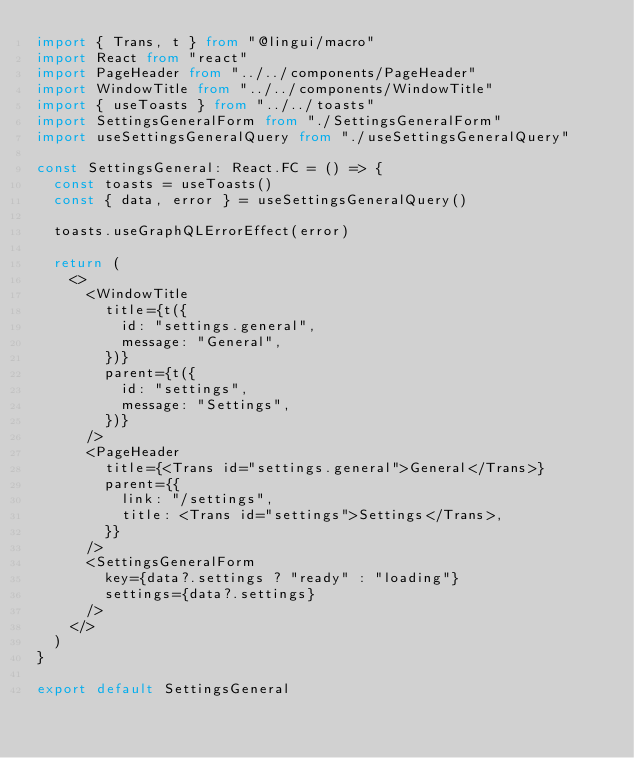<code> <loc_0><loc_0><loc_500><loc_500><_TypeScript_>import { Trans, t } from "@lingui/macro"
import React from "react"
import PageHeader from "../../components/PageHeader"
import WindowTitle from "../../components/WindowTitle"
import { useToasts } from "../../toasts"
import SettingsGeneralForm from "./SettingsGeneralForm"
import useSettingsGeneralQuery from "./useSettingsGeneralQuery"

const SettingsGeneral: React.FC = () => {
  const toasts = useToasts()
  const { data, error } = useSettingsGeneralQuery()

  toasts.useGraphQLErrorEffect(error)

  return (
    <>
      <WindowTitle
        title={t({
          id: "settings.general",
          message: "General",
        })}
        parent={t({
          id: "settings",
          message: "Settings",
        })}
      />
      <PageHeader
        title={<Trans id="settings.general">General</Trans>}
        parent={{
          link: "/settings",
          title: <Trans id="settings">Settings</Trans>,
        }}
      />
      <SettingsGeneralForm
        key={data?.settings ? "ready" : "loading"}
        settings={data?.settings}
      />
    </>
  )
}

export default SettingsGeneral
</code> 